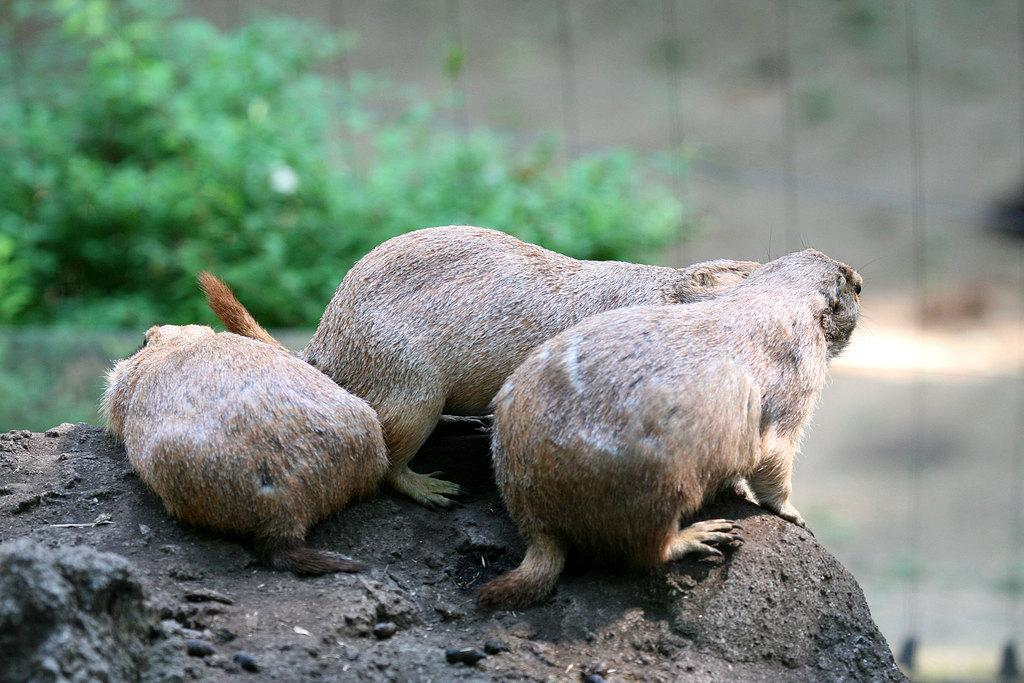What is located at the bottom of the image? There is a rock at the bottom of the image. What animals are in the middle of the image? There are three marmots in the middle of the image. What type of vegetation can be seen in the background of the image? There are trees in the background of the image. How would you describe the background of the image? The background of the image is blurred. What type of lead can be seen in the image? There is no lead present in the image. Is there a garden visible in the image? There is no garden visible in the image; it features a rock, marmots, trees, and a blurred background. 